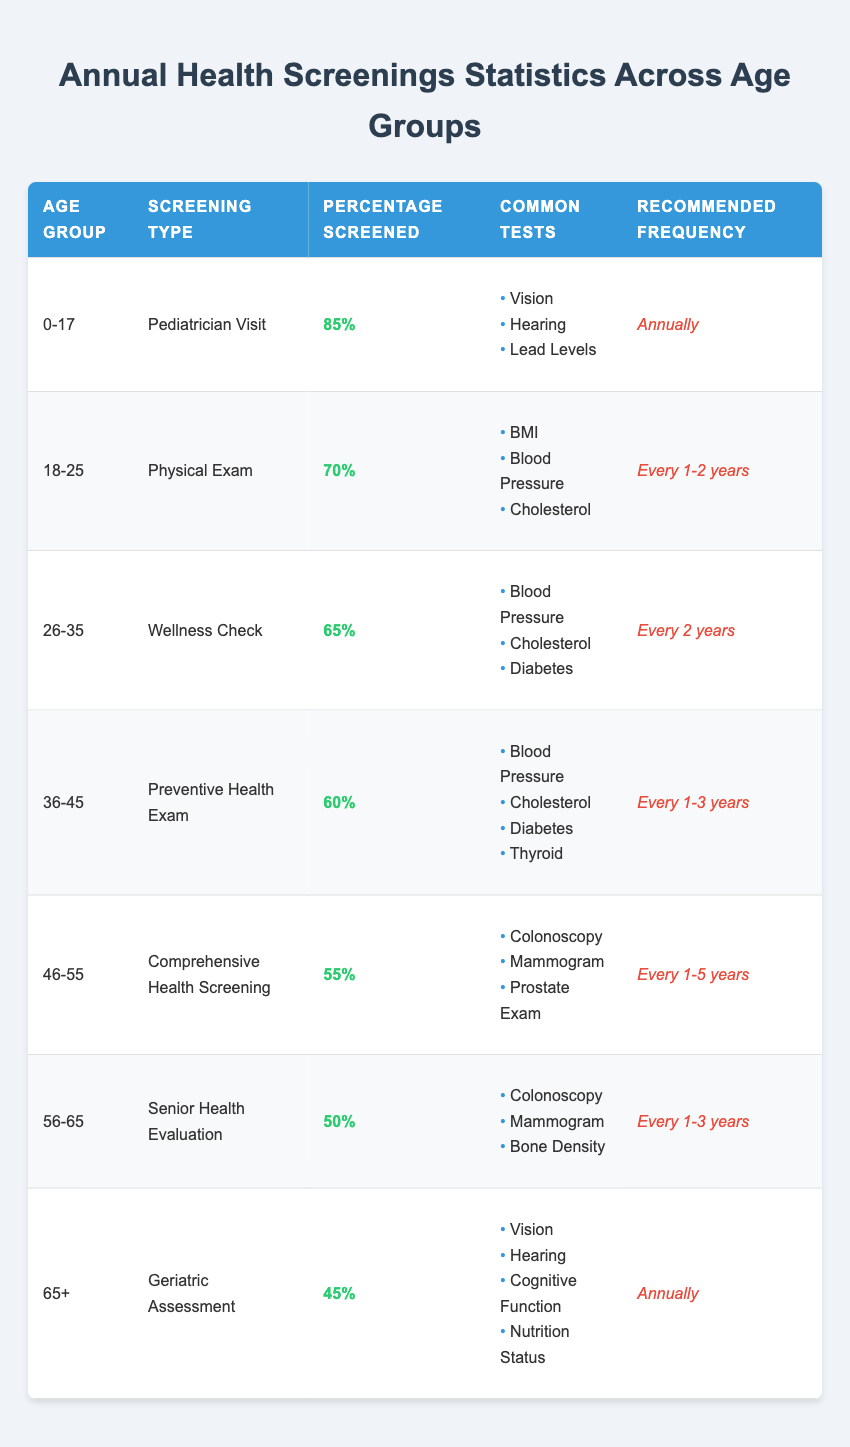What is the percentage of individuals screened in the 0-17 age group? The table states that the percentage screened for the 0-17 age group is explicitly recorded as 85%.
Answer: 85% Which age group has the lowest percentage screened? Upon reviewing the table, the age group 65+ has the lowest screening percentage listed, which is 45%.
Answer: 65+ What types of common tests are conducted for individuals aged 36-45? The common tests for the age group 36-45 are listed as Blood Pressure, Cholesterol, Diabetes, and Thyroid.
Answer: Blood Pressure, Cholesterol, Diabetes, and Thyroid How often is a senior health evaluation recommended for ages 56-65? The table indicates that individuals aged 56-65 should undergo a Senior Health Evaluation every 1-3 years.
Answer: Every 1-3 years What is the difference in screening percentages between the 18-25 and 26-35 age groups? The 18-25 age group's screening percentage is 70%, while the 26-35 age group's percentage is 65%. Therefore, the difference is 70% - 65% = 5%.
Answer: 5% If we take the average percentage of screenings across all age groups, what would it be? The percentages for each group are: 85, 70, 65, 60, 55, 50, and 45. Summing these gives 85 + 70 + 65 + 60 + 55 + 50 + 45 = 430. There are 7 groups, so the average is 430/7 = approximately 61.43%.
Answer: Approximately 61.43% Is it true that a comprehensive health screening is suggested every year for individuals aged 46-55? According to the table, a comprehensive health screening for those aged 46-55 is recommended every 1-5 years, not annually. Therefore, the statement is false.
Answer: False What percentage of those aged 18-25 and 36-45 have been screened combined? The percentage of those aged 18-25 is 70%, and for those aged 36-45, it is 60%. Therefore, combined, it is 70% + 60% = 130%.
Answer: 130% For which age group is a pediatrician visit recommended? The table specifies that a pediatrician visit is recommended for the age group 0-17.
Answer: 0-17 What percentage difference exists between the youngest and oldest age groups regarding screenings? The screening percentage for the 0-17 age group is 85%, while for the 65+ age group, it is 45%. Calculating the difference gives 85% - 45% = 40%.
Answer: 40% How many age groups recommend screenings annually? The age groups that recommend screenings annually are 0-17 and 65+. Therefore, there are 2 age groups that recommend annual screenings.
Answer: 2 